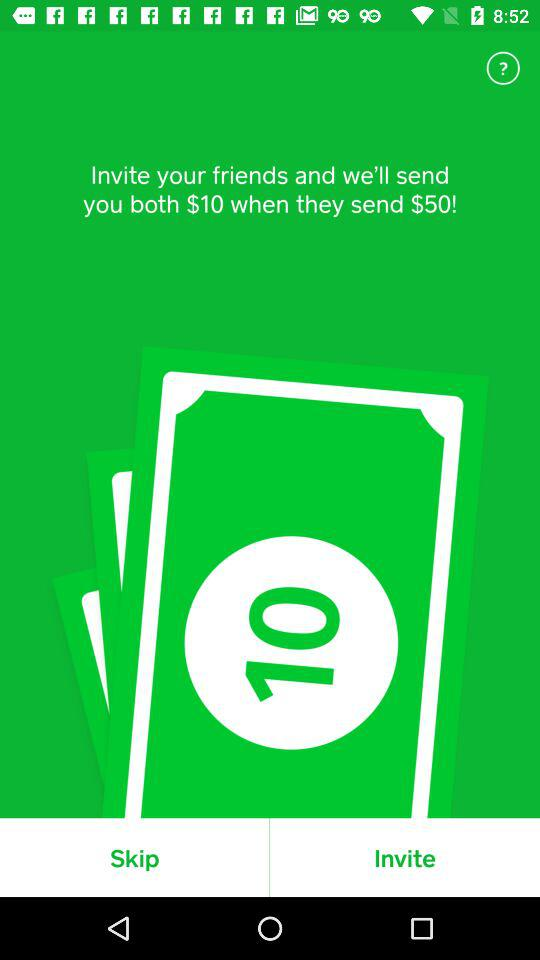How much money will you receive if you invite your friend and they send $50?
Answer the question using a single word or phrase. $10 